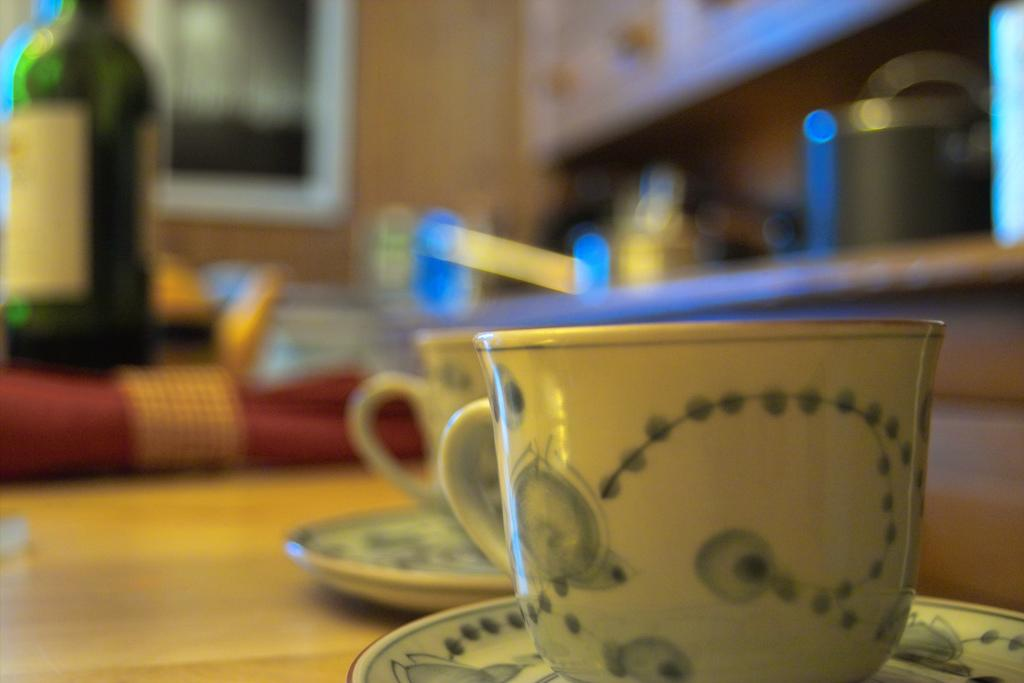How many cups are visible in the image? There are two cups in the image. What else is present with the cups? There are two saucers in the image. Where are the cups and saucers located? The cups and saucers are on a table. What can be seen in the background of the image? There is a wooden wall and unspecified objects in the background of the image. How many wings does the building have in the image? There is no building present in the image, so it is not possible to determine the number of wings. 